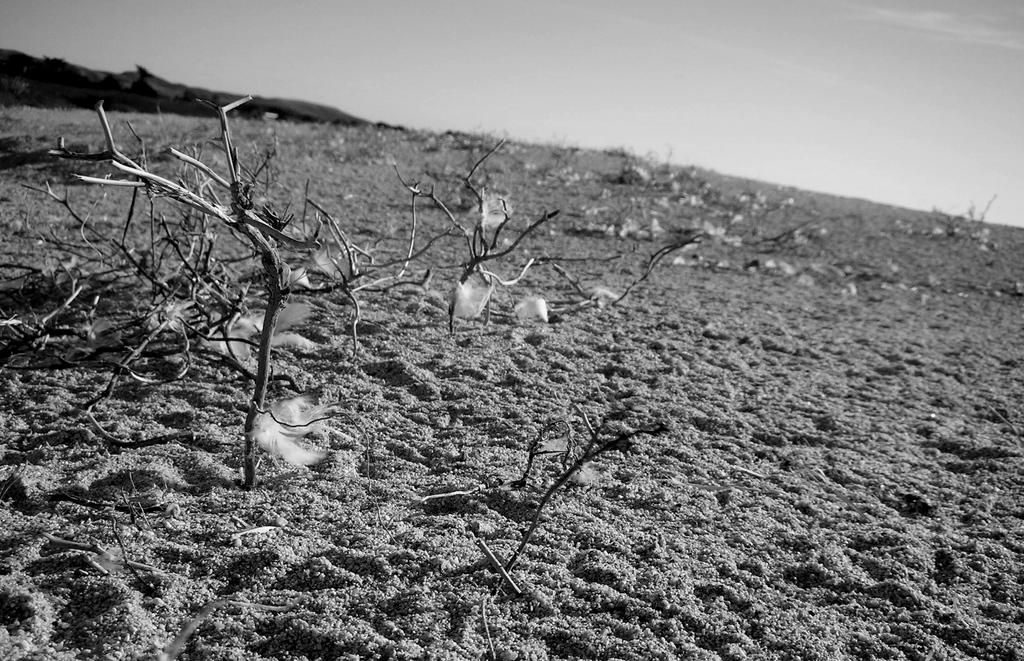What is the color scheme of the image? The image is black and white. What type of terrain is visible at the bottom of the image? There is sand at the bottom of the image. What can be seen in the middle of the image? There are small plants in the middle of the image. What is visible at the top of the image? The sky is visible at the top of the image. Can you see a volcano erupting in the image? There is no volcano present in the image. What type of rake is being used to maintain the small plants in the image? There is no rake visible in the image; the small plants are growing naturally. 